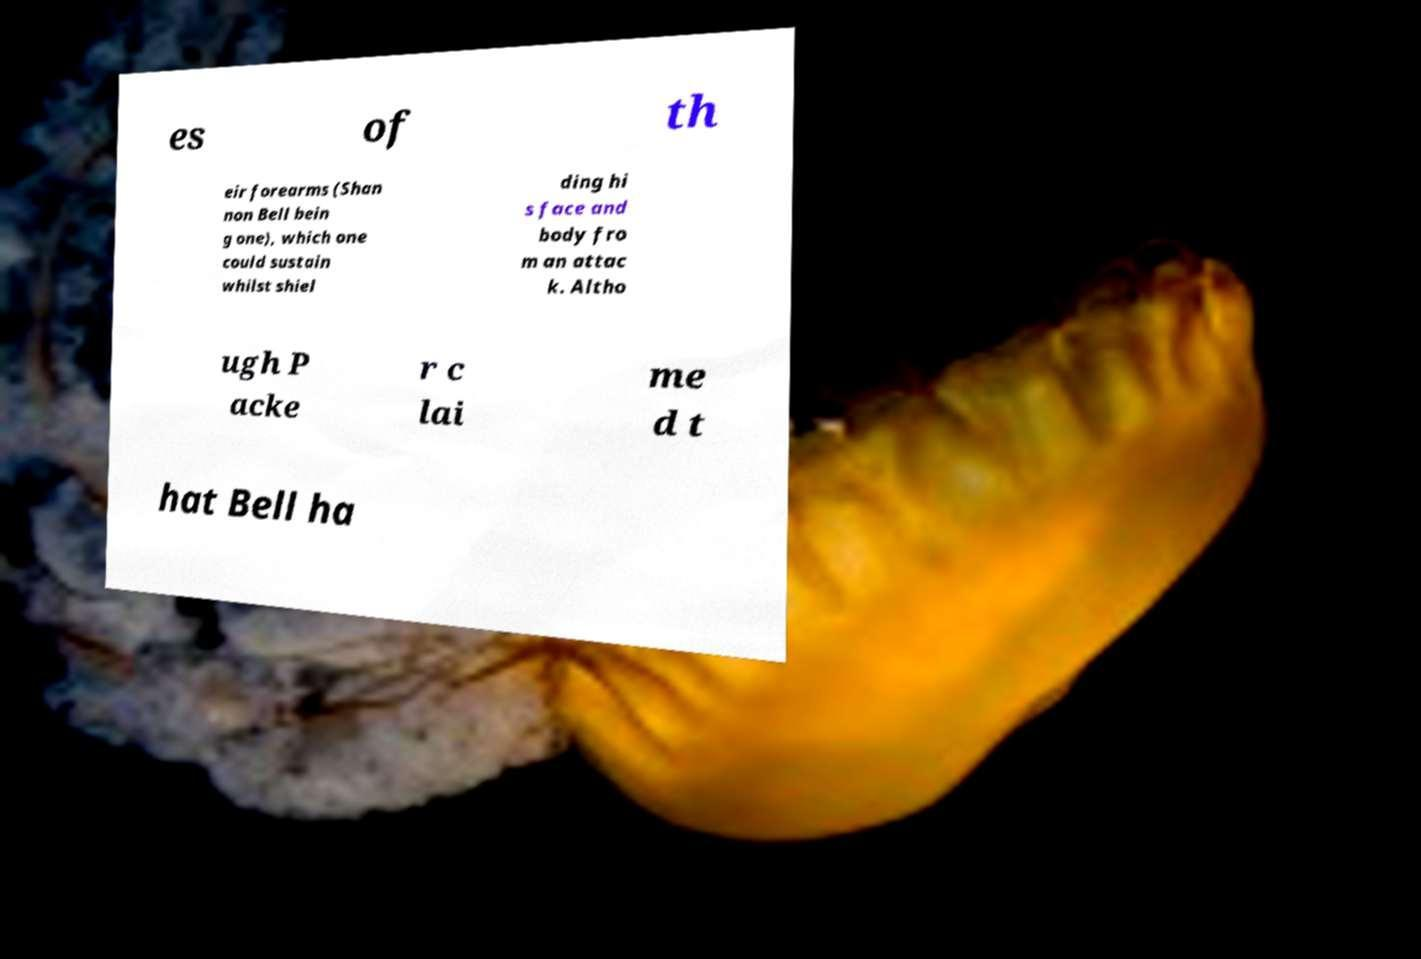Can you read and provide the text displayed in the image?This photo seems to have some interesting text. Can you extract and type it out for me? es of th eir forearms (Shan non Bell bein g one), which one could sustain whilst shiel ding hi s face and body fro m an attac k. Altho ugh P acke r c lai me d t hat Bell ha 